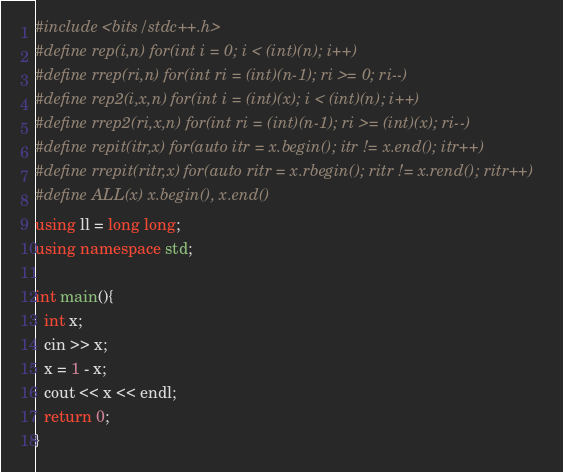<code> <loc_0><loc_0><loc_500><loc_500><_C++_>#include <bits/stdc++.h>
#define rep(i,n) for(int i = 0; i < (int)(n); i++)
#define rrep(ri,n) for(int ri = (int)(n-1); ri >= 0; ri--)
#define rep2(i,x,n) for(int i = (int)(x); i < (int)(n); i++)
#define rrep2(ri,x,n) for(int ri = (int)(n-1); ri >= (int)(x); ri--)
#define repit(itr,x) for(auto itr = x.begin(); itr != x.end(); itr++)
#define rrepit(ritr,x) for(auto ritr = x.rbegin(); ritr != x.rend(); ritr++)
#define ALL(x) x.begin(), x.end()
using ll = long long;
using namespace std;

int main(){
  int x;
  cin >> x;
  x = 1 - x;
  cout << x << endl;
  return 0;
}</code> 